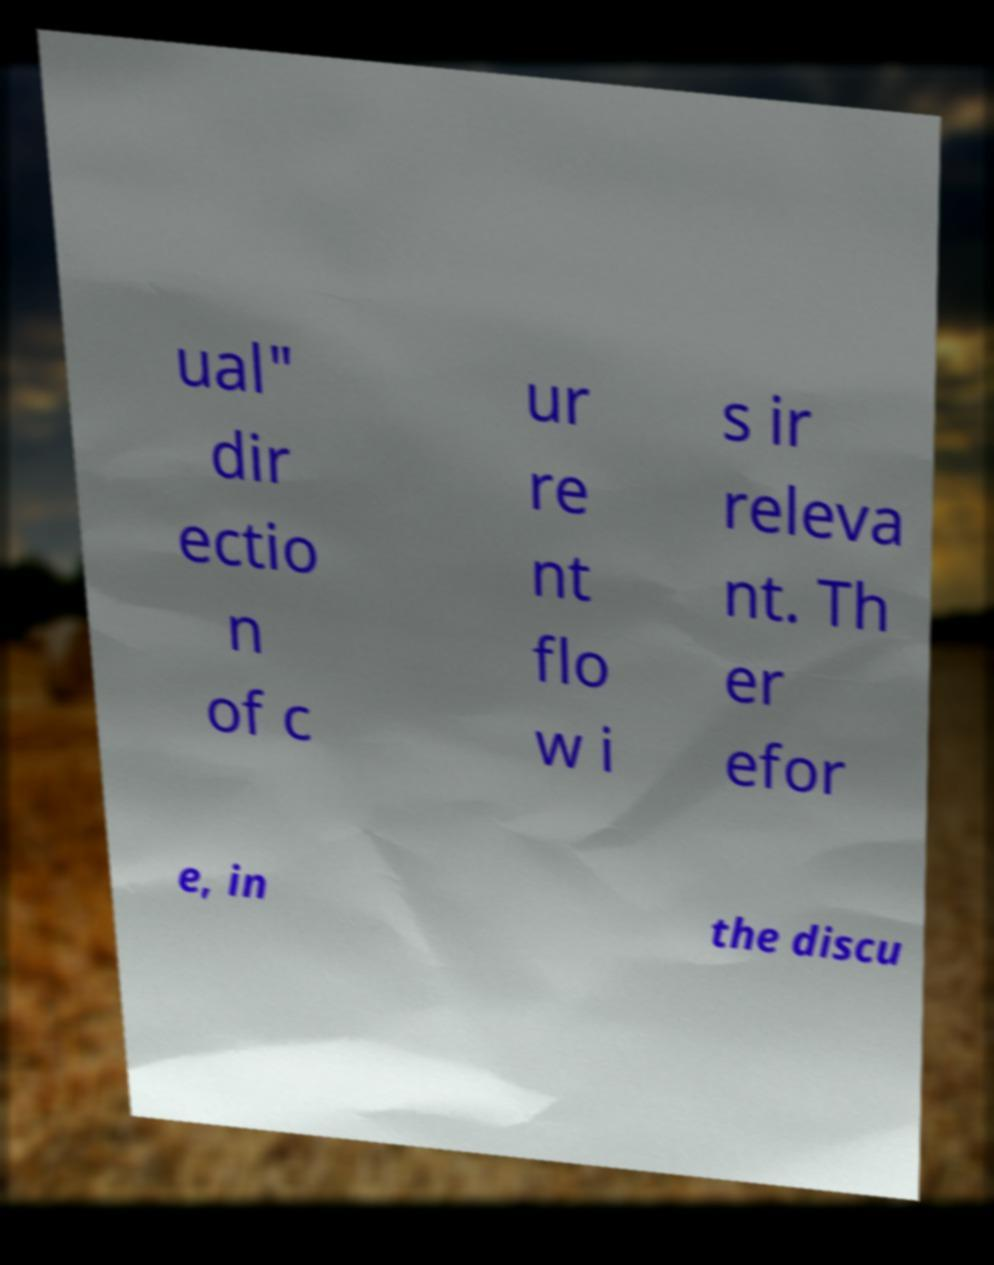For documentation purposes, I need the text within this image transcribed. Could you provide that? ual" dir ectio n of c ur re nt flo w i s ir releva nt. Th er efor e, in the discu 